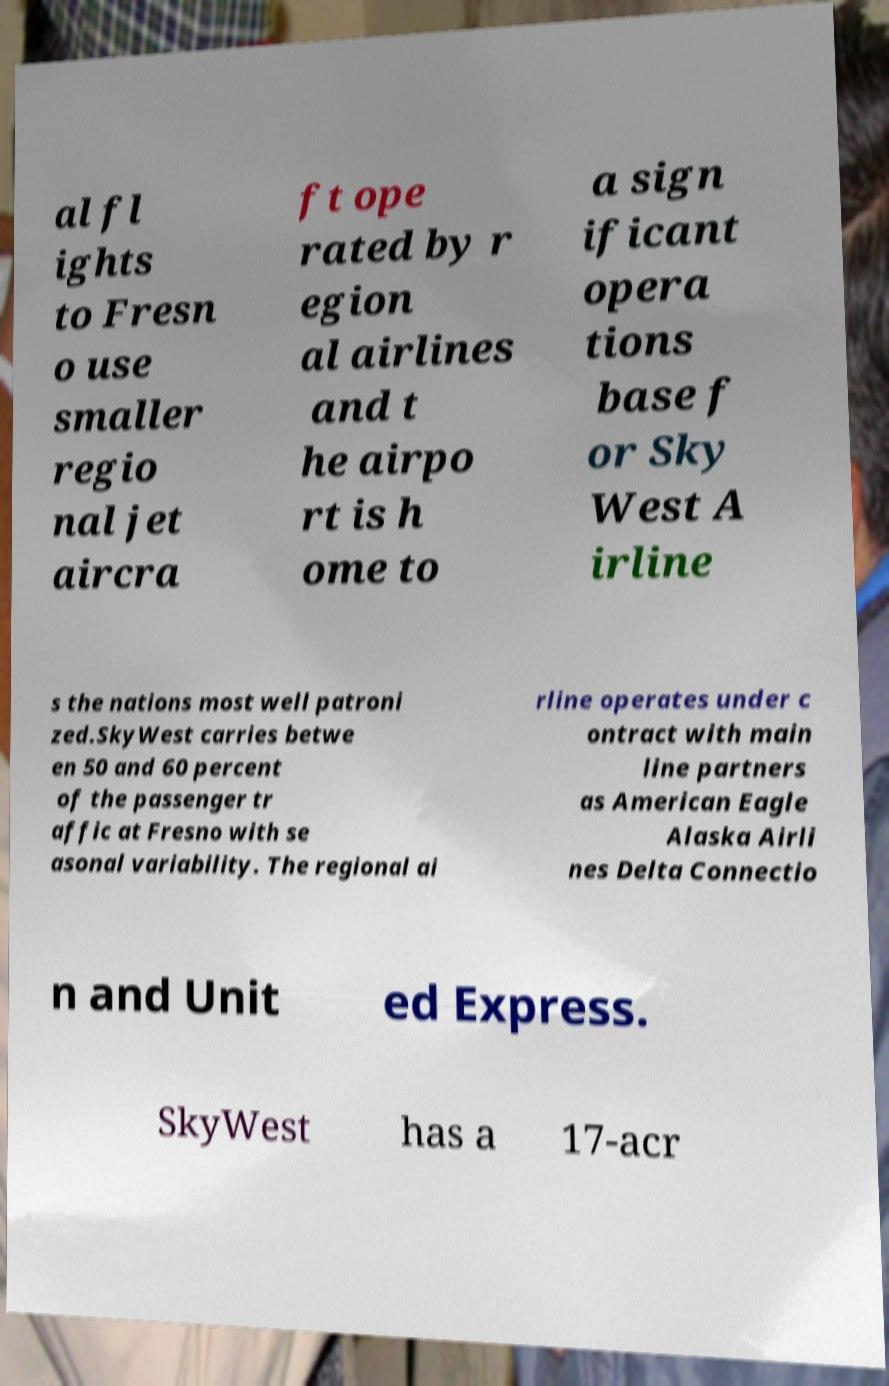There's text embedded in this image that I need extracted. Can you transcribe it verbatim? al fl ights to Fresn o use smaller regio nal jet aircra ft ope rated by r egion al airlines and t he airpo rt is h ome to a sign ificant opera tions base f or Sky West A irline s the nations most well patroni zed.SkyWest carries betwe en 50 and 60 percent of the passenger tr affic at Fresno with se asonal variability. The regional ai rline operates under c ontract with main line partners as American Eagle Alaska Airli nes Delta Connectio n and Unit ed Express. SkyWest has a 17-acr 